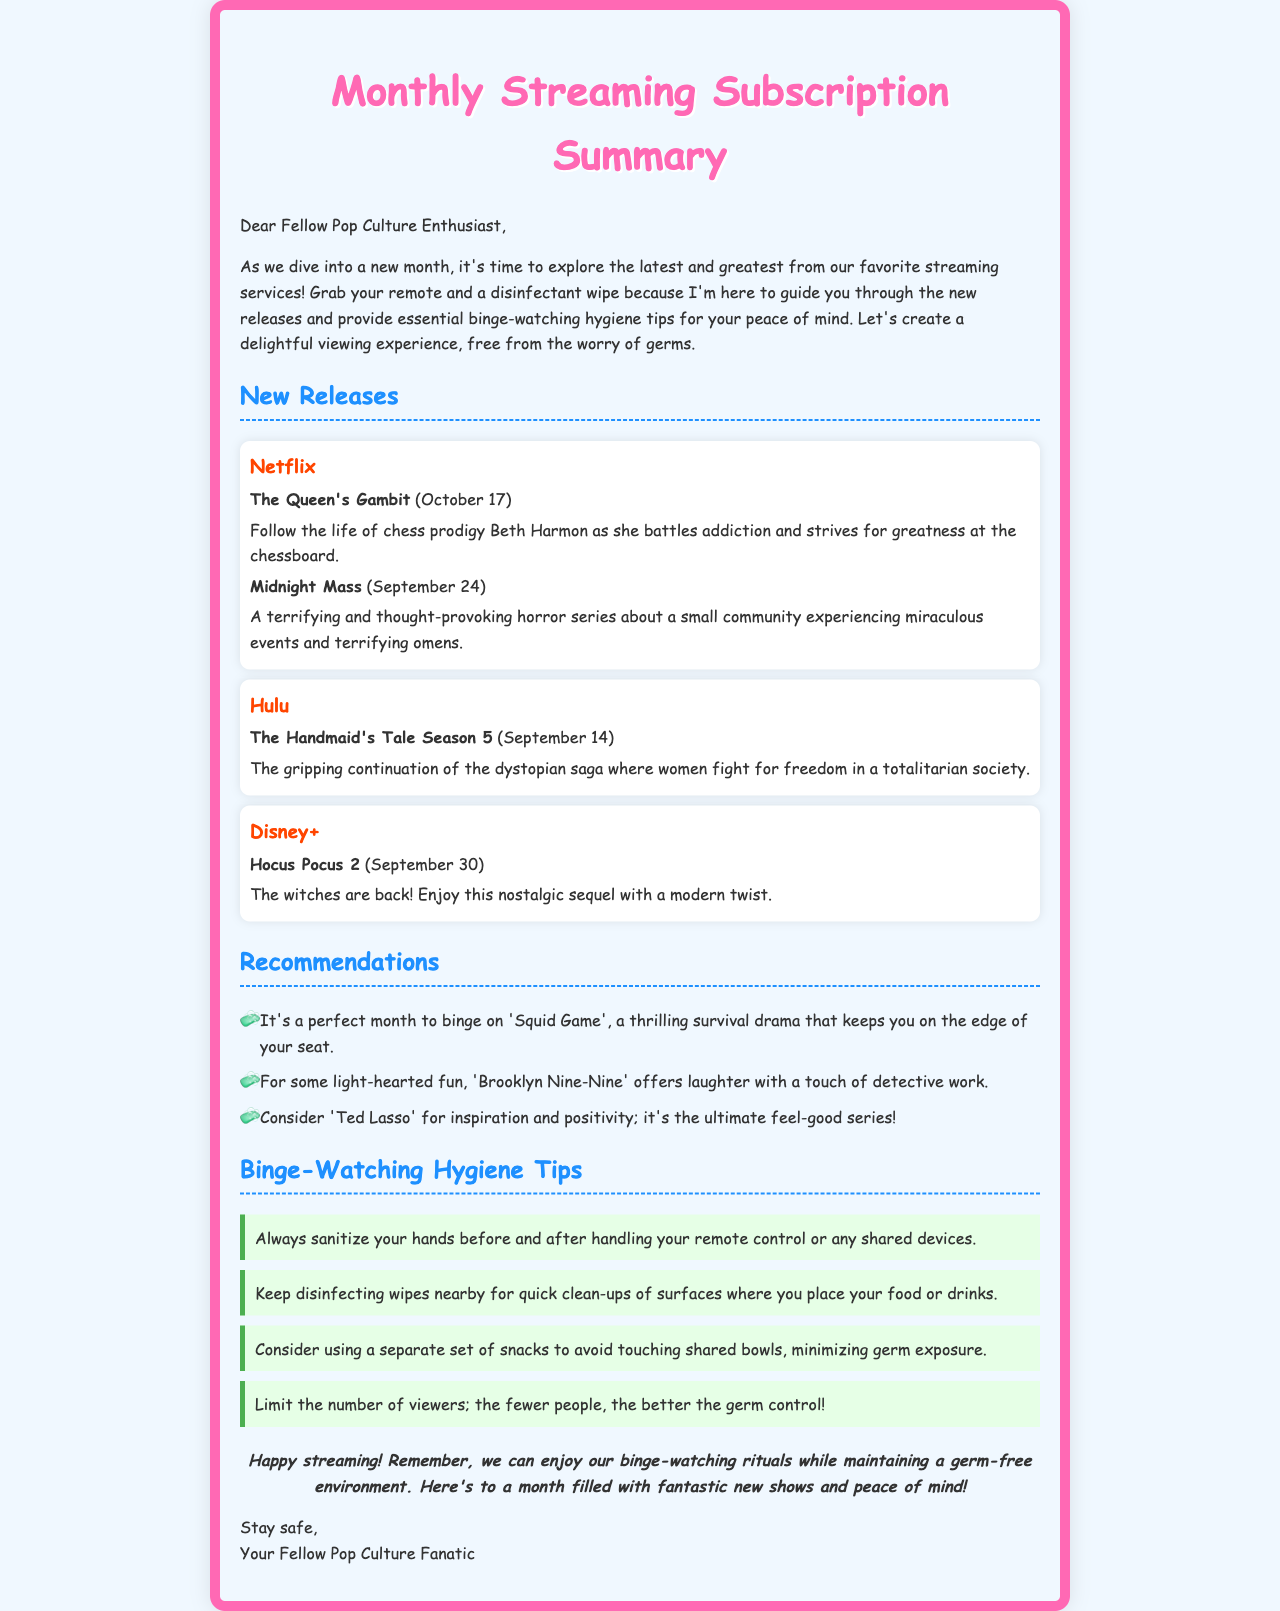what is the title of the document? The title of the document is provided in the header section of the HTML.
Answer: Monthly Streaming Subscription Summary when was The Queen's Gambit released? The release date for The Queen's Gambit is mentioned under the Netflix section.
Answer: October 17 which streaming service has Hocus Pocus 2? The document details different streaming services and their new releases.
Answer: Disney+ name one recommendation for light-hearted fun. The recommendations list includes shows that cater to different moods.
Answer: Brooklyn Nine-Nine how many hygiene tips are provided? The hygiene tips are listed in a dedicated section of the document.
Answer: Four which series continues the story of women fighting for freedom? This information can be found in the Hulu new releases section.
Answer: The Handmaid's Tale Season 5 what type of document is this? The document's structure and content indicate its format and purpose.
Answer: Letter what is the background color of the document? The background color is described in the CSS style section of the HTML.
Answer: Light blue 